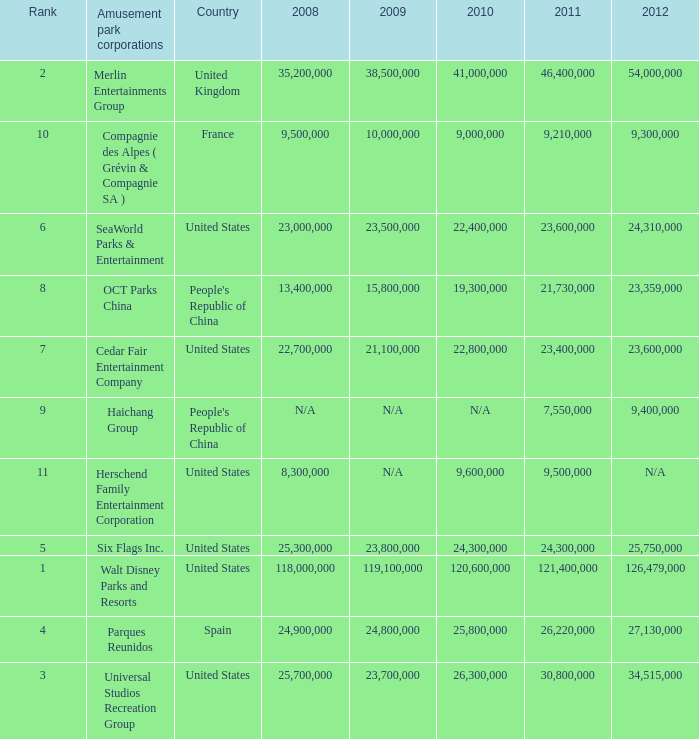In the United States the 2011 attendance at this amusement park corporation was larger than 30,800,000 but lists what as its 2008 attendance? 118000000.0. 